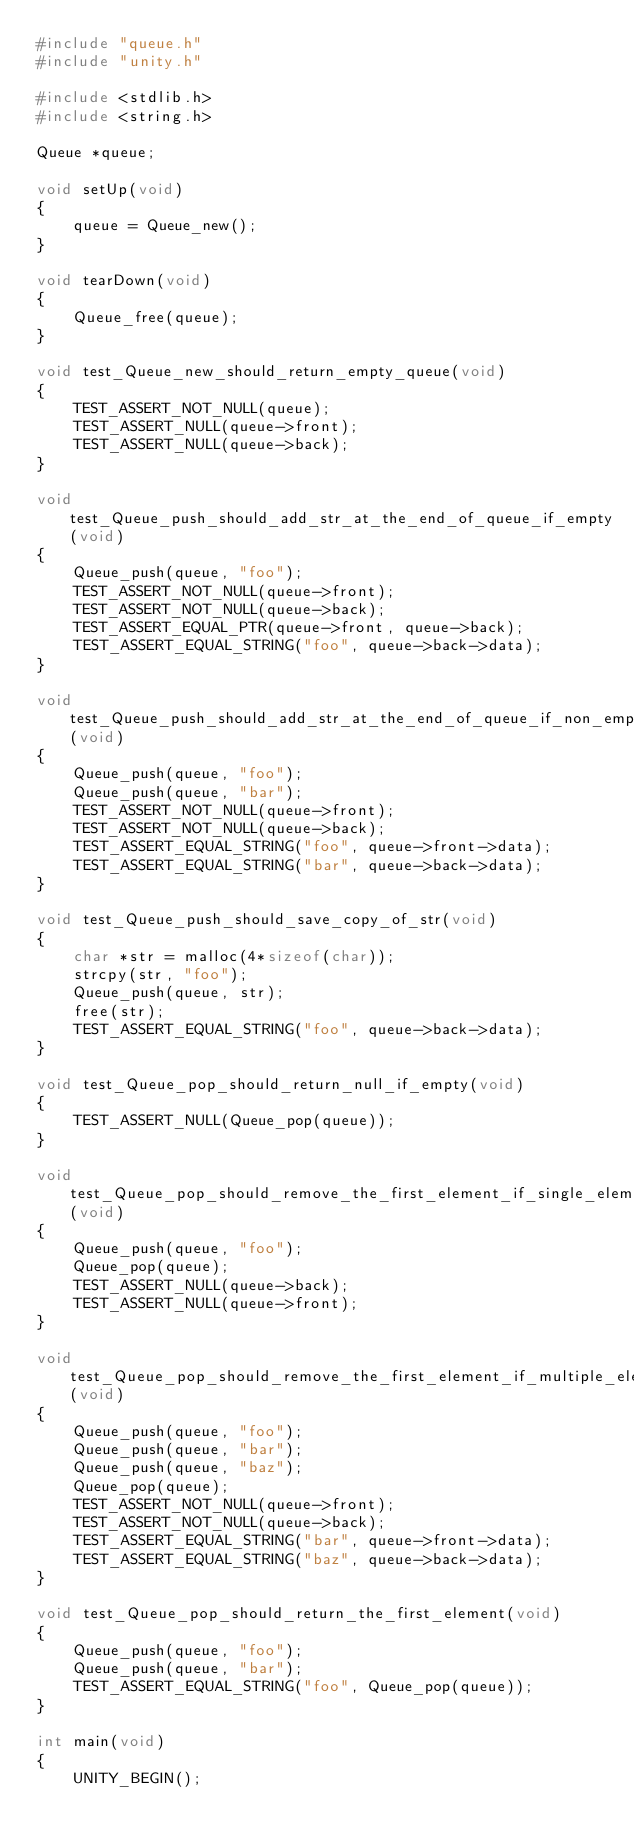<code> <loc_0><loc_0><loc_500><loc_500><_C_>#include "queue.h"
#include "unity.h"

#include <stdlib.h>
#include <string.h>

Queue *queue;

void setUp(void)
{
	queue = Queue_new();
}

void tearDown(void)
{
	Queue_free(queue);
}

void test_Queue_new_should_return_empty_queue(void)
{
	TEST_ASSERT_NOT_NULL(queue);
	TEST_ASSERT_NULL(queue->front);
	TEST_ASSERT_NULL(queue->back);
}

void test_Queue_push_should_add_str_at_the_end_of_queue_if_empty(void)
{
	Queue_push(queue, "foo");
	TEST_ASSERT_NOT_NULL(queue->front);
	TEST_ASSERT_NOT_NULL(queue->back);
	TEST_ASSERT_EQUAL_PTR(queue->front, queue->back);
	TEST_ASSERT_EQUAL_STRING("foo", queue->back->data);
}

void test_Queue_push_should_add_str_at_the_end_of_queue_if_non_empty(void)
{
	Queue_push(queue, "foo");
	Queue_push(queue, "bar");
	TEST_ASSERT_NOT_NULL(queue->front);
	TEST_ASSERT_NOT_NULL(queue->back);
	TEST_ASSERT_EQUAL_STRING("foo", queue->front->data);
	TEST_ASSERT_EQUAL_STRING("bar", queue->back->data);
}

void test_Queue_push_should_save_copy_of_str(void)
{
	char *str = malloc(4*sizeof(char));
	strcpy(str, "foo");
	Queue_push(queue, str);
	free(str);
	TEST_ASSERT_EQUAL_STRING("foo", queue->back->data);
}

void test_Queue_pop_should_return_null_if_empty(void)
{
	TEST_ASSERT_NULL(Queue_pop(queue));
}

void test_Queue_pop_should_remove_the_first_element_if_single_element(void)
{
	Queue_push(queue, "foo");
	Queue_pop(queue);
	TEST_ASSERT_NULL(queue->back);
	TEST_ASSERT_NULL(queue->front);
}

void test_Queue_pop_should_remove_the_first_element_if_multiple_elements(void)
{
	Queue_push(queue, "foo");
	Queue_push(queue, "bar");
	Queue_push(queue, "baz");
	Queue_pop(queue);
	TEST_ASSERT_NOT_NULL(queue->front);
	TEST_ASSERT_NOT_NULL(queue->back);
	TEST_ASSERT_EQUAL_STRING("bar", queue->front->data);
	TEST_ASSERT_EQUAL_STRING("baz", queue->back->data);
}

void test_Queue_pop_should_return_the_first_element(void)
{
	Queue_push(queue, "foo");
	Queue_push(queue, "bar");
	TEST_ASSERT_EQUAL_STRING("foo", Queue_pop(queue));
}

int main(void)
{
	UNITY_BEGIN();</code> 